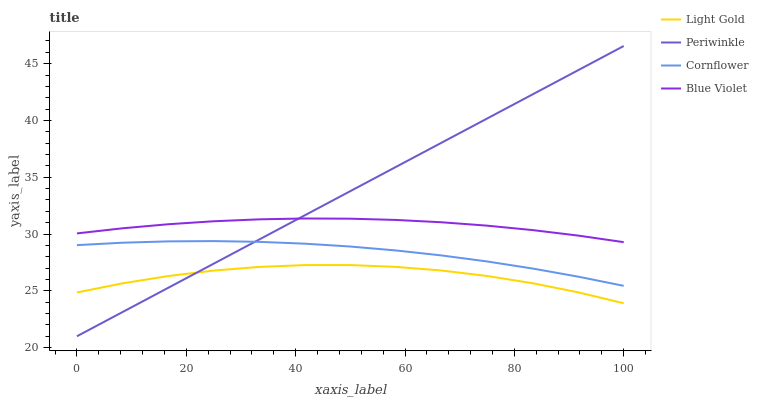Does Light Gold have the minimum area under the curve?
Answer yes or no. Yes. Does Periwinkle have the maximum area under the curve?
Answer yes or no. Yes. Does Blue Violet have the minimum area under the curve?
Answer yes or no. No. Does Blue Violet have the maximum area under the curve?
Answer yes or no. No. Is Periwinkle the smoothest?
Answer yes or no. Yes. Is Light Gold the roughest?
Answer yes or no. Yes. Is Blue Violet the smoothest?
Answer yes or no. No. Is Blue Violet the roughest?
Answer yes or no. No. Does Periwinkle have the lowest value?
Answer yes or no. Yes. Does Light Gold have the lowest value?
Answer yes or no. No. Does Periwinkle have the highest value?
Answer yes or no. Yes. Does Blue Violet have the highest value?
Answer yes or no. No. Is Cornflower less than Blue Violet?
Answer yes or no. Yes. Is Blue Violet greater than Cornflower?
Answer yes or no. Yes. Does Periwinkle intersect Blue Violet?
Answer yes or no. Yes. Is Periwinkle less than Blue Violet?
Answer yes or no. No. Is Periwinkle greater than Blue Violet?
Answer yes or no. No. Does Cornflower intersect Blue Violet?
Answer yes or no. No. 